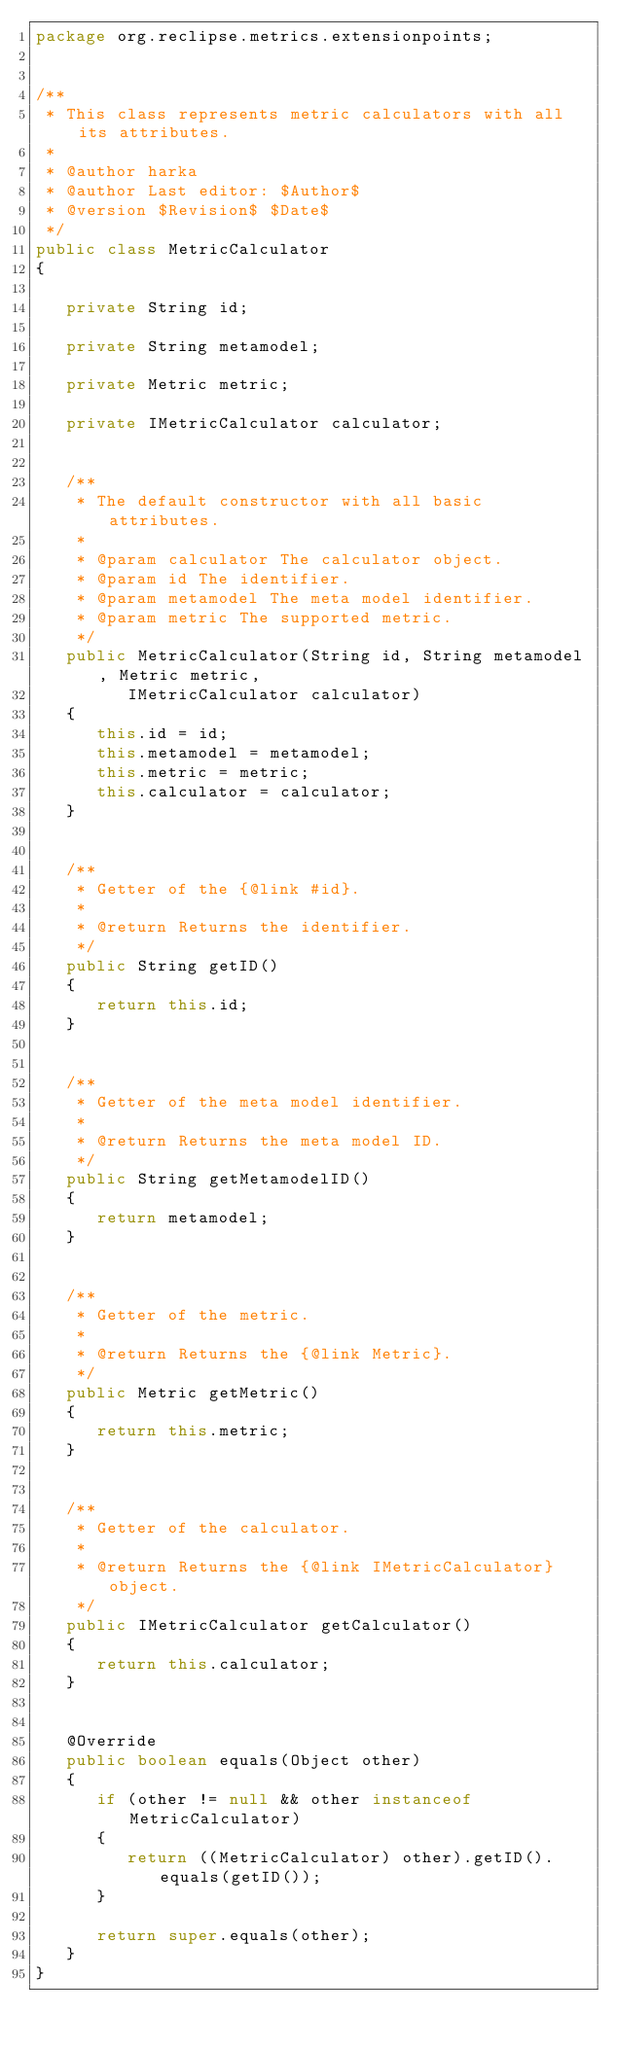Convert code to text. <code><loc_0><loc_0><loc_500><loc_500><_Java_>package org.reclipse.metrics.extensionpoints;


/**
 * This class represents metric calculators with all its attributes.
 * 
 * @author harka
 * @author Last editor: $Author$
 * @version $Revision$ $Date$
 */
public class MetricCalculator
{

   private String id;

   private String metamodel;

   private Metric metric;

   private IMetricCalculator calculator;


   /**
    * The default constructor with all basic attributes.
    * 
    * @param calculator The calculator object.
    * @param id The identifier.
    * @param metamodel The meta model identifier.
    * @param metric The supported metric.
    */
   public MetricCalculator(String id, String metamodel, Metric metric,
         IMetricCalculator calculator)
   {
      this.id = id;
      this.metamodel = metamodel;
      this.metric = metric;
      this.calculator = calculator;
   }


   /**
    * Getter of the {@link #id}.
    * 
    * @return Returns the identifier.
    */
   public String getID()
   {
      return this.id;
   }


   /**
    * Getter of the meta model identifier.
    * 
    * @return Returns the meta model ID.
    */
   public String getMetamodelID()
   {
      return metamodel;
   }


   /**
    * Getter of the metric.
    * 
    * @return Returns the {@link Metric}.
    */
   public Metric getMetric()
   {
      return this.metric;
   }


   /**
    * Getter of the calculator.
    * 
    * @return Returns the {@link IMetricCalculator} object.
    */
   public IMetricCalculator getCalculator()
   {
      return this.calculator;
   }


   @Override
   public boolean equals(Object other)
   {
      if (other != null && other instanceof MetricCalculator)
      {
         return ((MetricCalculator) other).getID().equals(getID());
      }

      return super.equals(other);
   }
}
</code> 